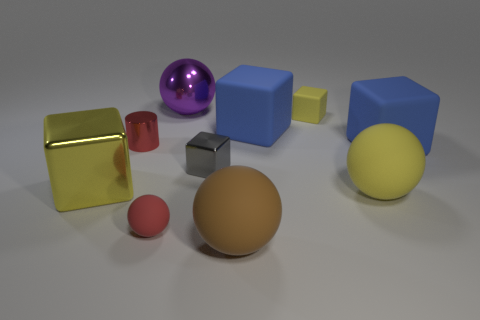Are there any other things of the same color as the big metal block?
Give a very brief answer. Yes. What is the color of the metallic object that is the same shape as the tiny red rubber object?
Provide a succinct answer. Purple. There is a large object behind the small matte thing that is behind the big yellow metal block; what color is it?
Give a very brief answer. Purple. There is a yellow thing that is the same shape as the large purple thing; what is its size?
Provide a short and direct response. Large. How many purple balls have the same material as the red cylinder?
Your answer should be compact. 1. There is a red thing that is left of the small red ball; how many big blue blocks are behind it?
Make the answer very short. 1. Are there any tiny matte things on the left side of the red cylinder?
Offer a terse response. No. Does the small rubber object on the right side of the big purple thing have the same shape as the gray object?
Your response must be concise. Yes. There is a tiny sphere that is the same color as the small metallic cylinder; what is it made of?
Give a very brief answer. Rubber. What number of small shiny objects have the same color as the large metal block?
Provide a succinct answer. 0. 